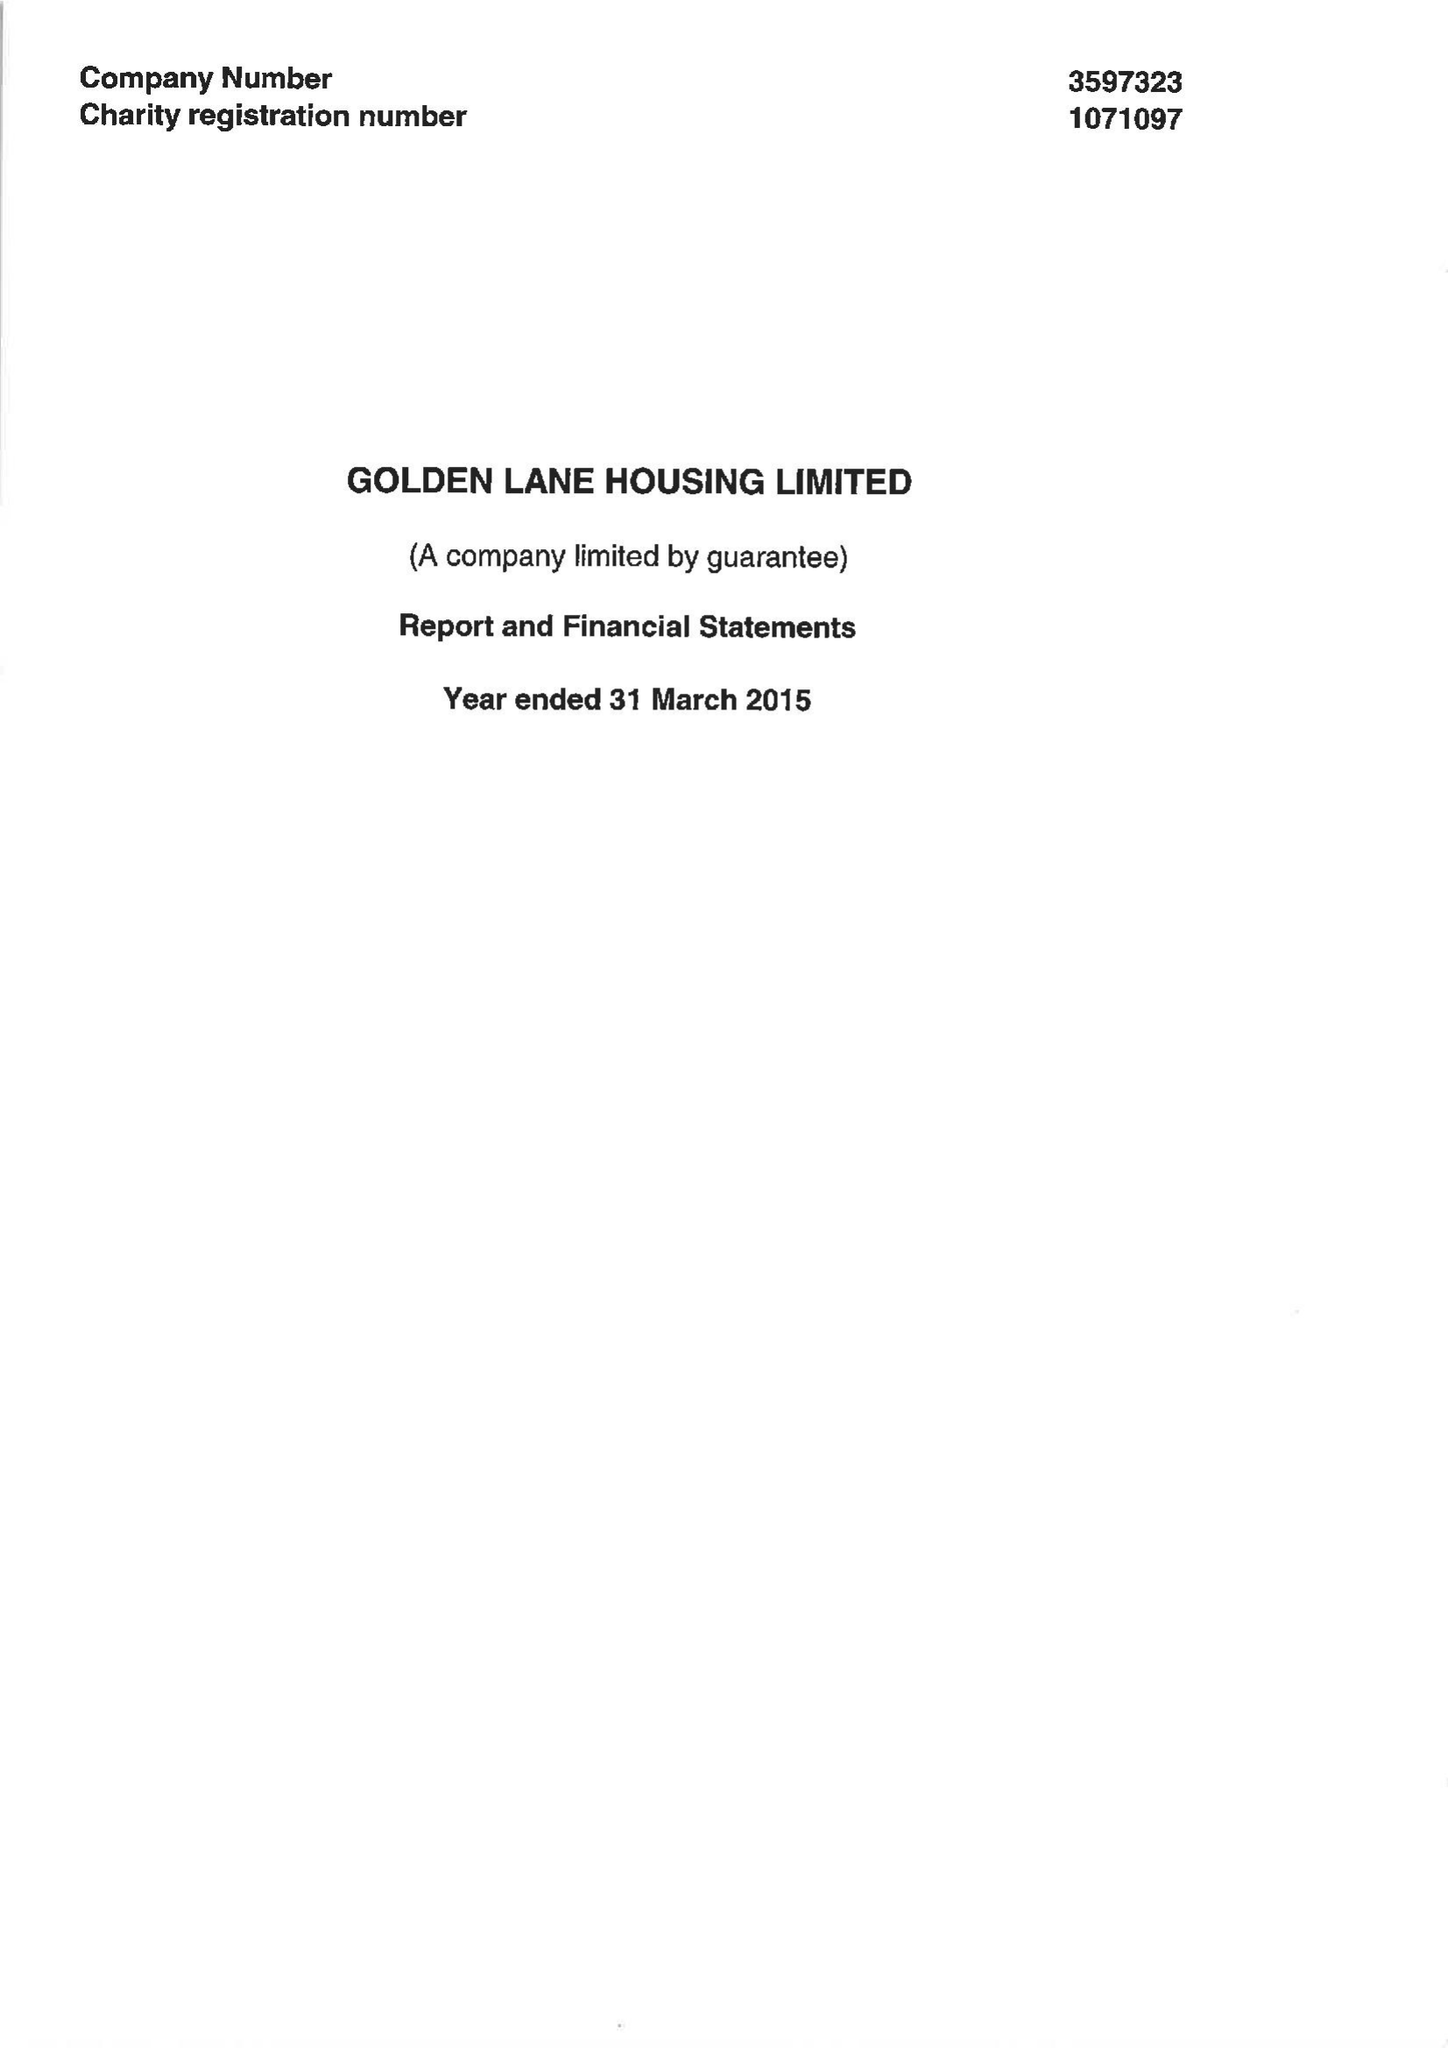What is the value for the income_annually_in_british_pounds?
Answer the question using a single word or phrase. 12053387.00 